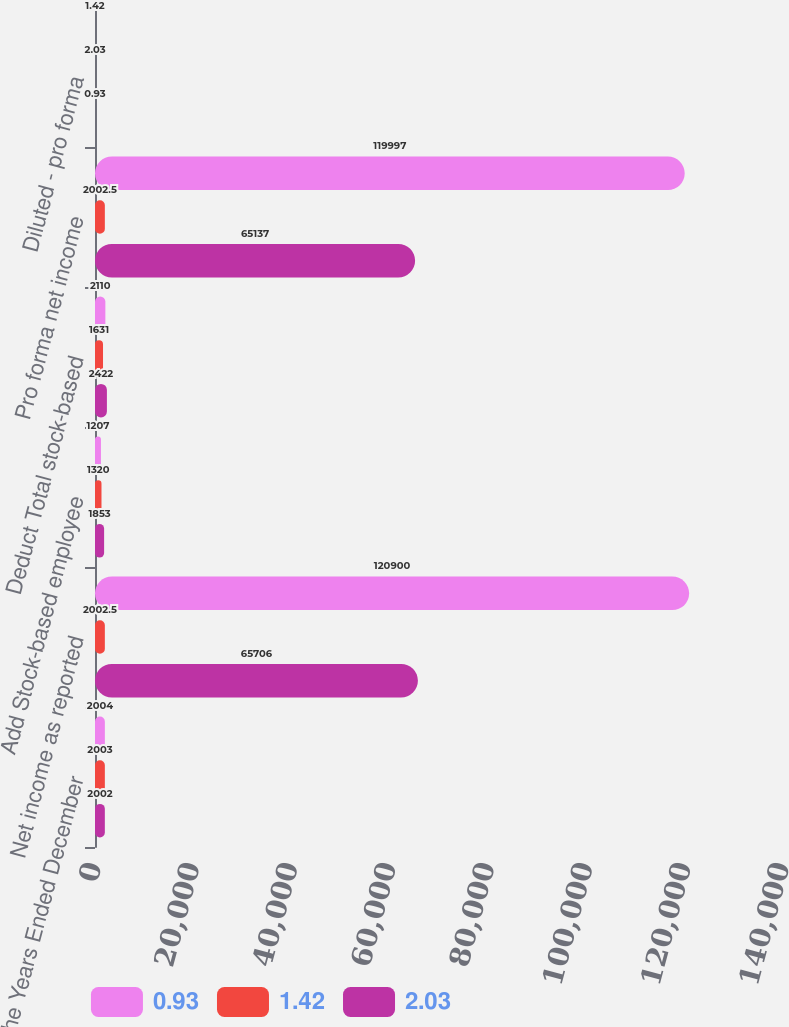<chart> <loc_0><loc_0><loc_500><loc_500><stacked_bar_chart><ecel><fcel>For the Years Ended December<fcel>Net income as reported<fcel>Add Stock-based employee<fcel>Deduct Total stock-based<fcel>Pro forma net income<fcel>Diluted - pro forma<nl><fcel>0.93<fcel>2004<fcel>120900<fcel>1207<fcel>2110<fcel>119997<fcel>1.42<nl><fcel>1.42<fcel>2003<fcel>2002.5<fcel>1320<fcel>1631<fcel>2002.5<fcel>2.03<nl><fcel>2.03<fcel>2002<fcel>65706<fcel>1853<fcel>2422<fcel>65137<fcel>0.93<nl></chart> 